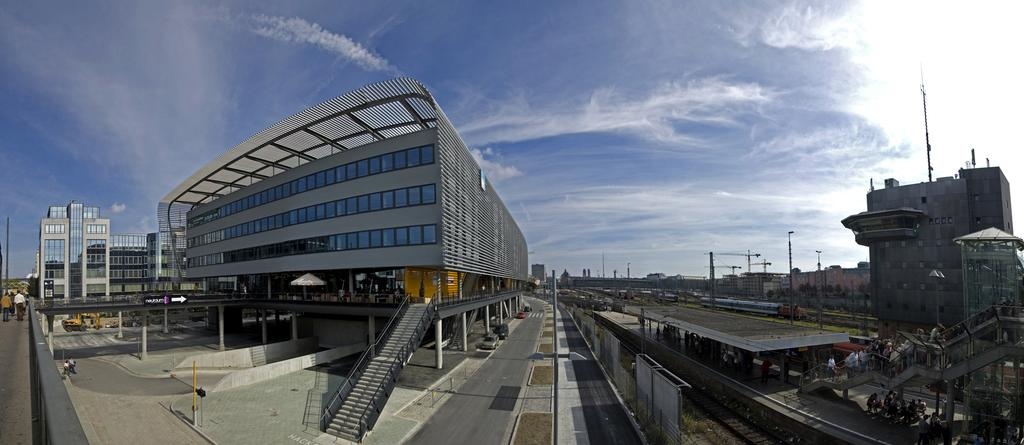What type of structure is visible in the image? There is a building in the image. Where are the people located in the image? The people are on the right side of the image. What can be seen in the sky in the background? There are clouds in the sky in the background. Are there any other buildings visible in the image? Yes, there is another building on the left side of the image. What type of music can be heard coming from the building on the left side of the image? There is no indication of music or any sounds in the image, so it's not possible to determine what, if any, music might be heard. 